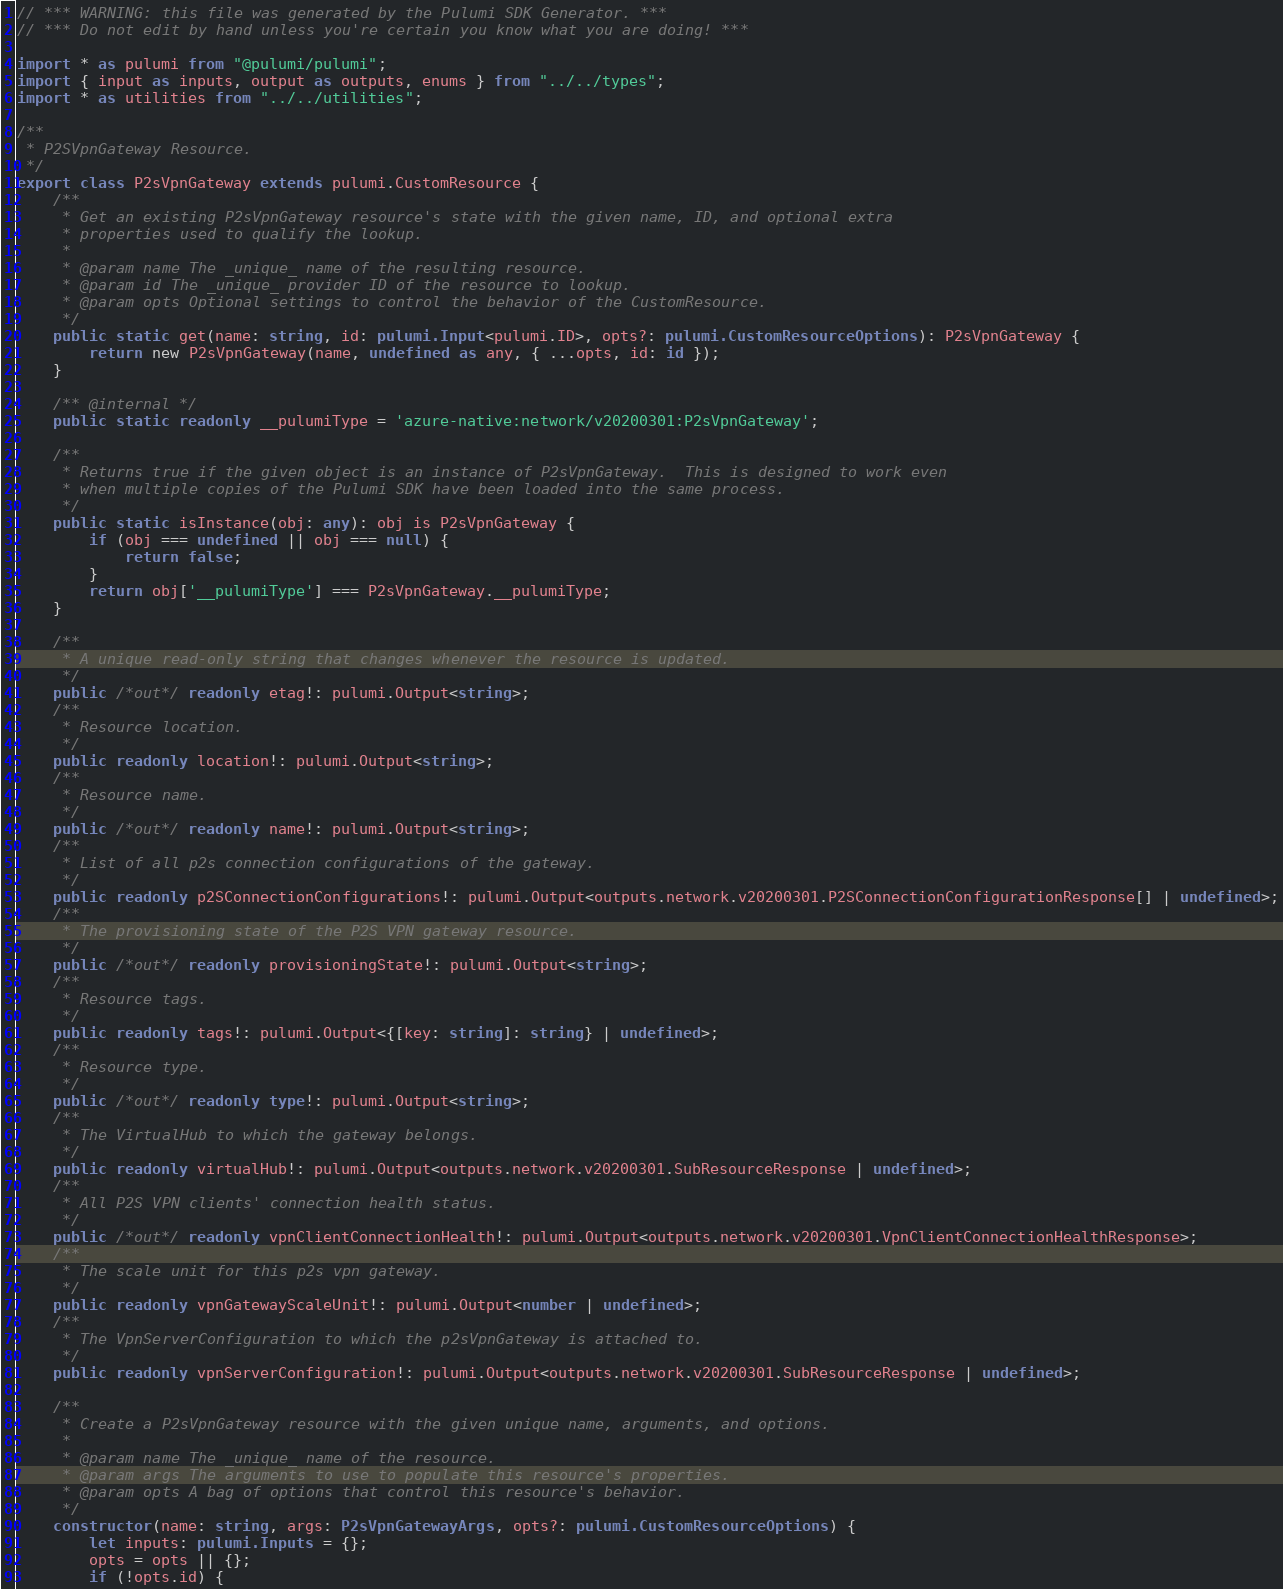Convert code to text. <code><loc_0><loc_0><loc_500><loc_500><_TypeScript_>// *** WARNING: this file was generated by the Pulumi SDK Generator. ***
// *** Do not edit by hand unless you're certain you know what you are doing! ***

import * as pulumi from "@pulumi/pulumi";
import { input as inputs, output as outputs, enums } from "../../types";
import * as utilities from "../../utilities";

/**
 * P2SVpnGateway Resource.
 */
export class P2sVpnGateway extends pulumi.CustomResource {
    /**
     * Get an existing P2sVpnGateway resource's state with the given name, ID, and optional extra
     * properties used to qualify the lookup.
     *
     * @param name The _unique_ name of the resulting resource.
     * @param id The _unique_ provider ID of the resource to lookup.
     * @param opts Optional settings to control the behavior of the CustomResource.
     */
    public static get(name: string, id: pulumi.Input<pulumi.ID>, opts?: pulumi.CustomResourceOptions): P2sVpnGateway {
        return new P2sVpnGateway(name, undefined as any, { ...opts, id: id });
    }

    /** @internal */
    public static readonly __pulumiType = 'azure-native:network/v20200301:P2sVpnGateway';

    /**
     * Returns true if the given object is an instance of P2sVpnGateway.  This is designed to work even
     * when multiple copies of the Pulumi SDK have been loaded into the same process.
     */
    public static isInstance(obj: any): obj is P2sVpnGateway {
        if (obj === undefined || obj === null) {
            return false;
        }
        return obj['__pulumiType'] === P2sVpnGateway.__pulumiType;
    }

    /**
     * A unique read-only string that changes whenever the resource is updated.
     */
    public /*out*/ readonly etag!: pulumi.Output<string>;
    /**
     * Resource location.
     */
    public readonly location!: pulumi.Output<string>;
    /**
     * Resource name.
     */
    public /*out*/ readonly name!: pulumi.Output<string>;
    /**
     * List of all p2s connection configurations of the gateway.
     */
    public readonly p2SConnectionConfigurations!: pulumi.Output<outputs.network.v20200301.P2SConnectionConfigurationResponse[] | undefined>;
    /**
     * The provisioning state of the P2S VPN gateway resource.
     */
    public /*out*/ readonly provisioningState!: pulumi.Output<string>;
    /**
     * Resource tags.
     */
    public readonly tags!: pulumi.Output<{[key: string]: string} | undefined>;
    /**
     * Resource type.
     */
    public /*out*/ readonly type!: pulumi.Output<string>;
    /**
     * The VirtualHub to which the gateway belongs.
     */
    public readonly virtualHub!: pulumi.Output<outputs.network.v20200301.SubResourceResponse | undefined>;
    /**
     * All P2S VPN clients' connection health status.
     */
    public /*out*/ readonly vpnClientConnectionHealth!: pulumi.Output<outputs.network.v20200301.VpnClientConnectionHealthResponse>;
    /**
     * The scale unit for this p2s vpn gateway.
     */
    public readonly vpnGatewayScaleUnit!: pulumi.Output<number | undefined>;
    /**
     * The VpnServerConfiguration to which the p2sVpnGateway is attached to.
     */
    public readonly vpnServerConfiguration!: pulumi.Output<outputs.network.v20200301.SubResourceResponse | undefined>;

    /**
     * Create a P2sVpnGateway resource with the given unique name, arguments, and options.
     *
     * @param name The _unique_ name of the resource.
     * @param args The arguments to use to populate this resource's properties.
     * @param opts A bag of options that control this resource's behavior.
     */
    constructor(name: string, args: P2sVpnGatewayArgs, opts?: pulumi.CustomResourceOptions) {
        let inputs: pulumi.Inputs = {};
        opts = opts || {};
        if (!opts.id) {</code> 